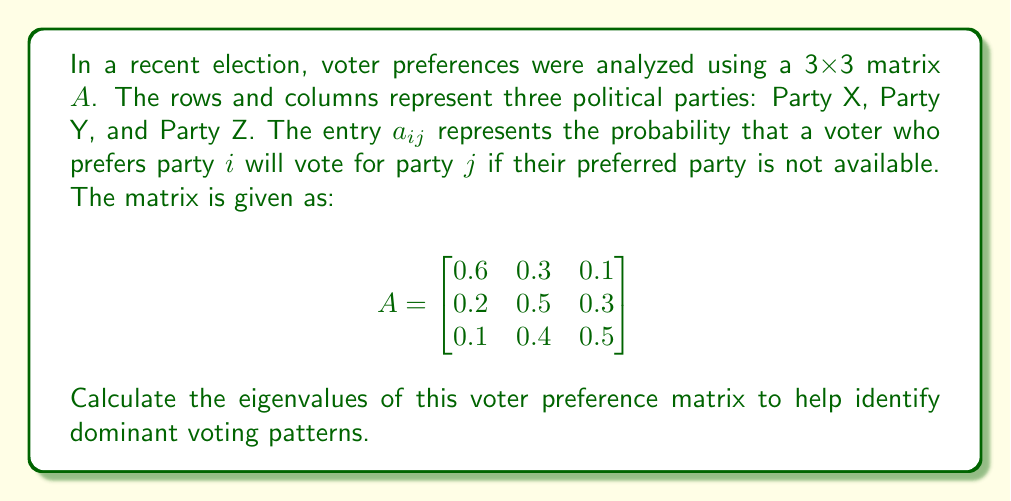Provide a solution to this math problem. To find the eigenvalues of matrix $A$, we need to solve the characteristic equation:

$\det(A - \lambda I) = 0$

where $I$ is the 3x3 identity matrix and $\lambda$ represents the eigenvalues.

Step 1: Set up the characteristic equation:
$$\det\begin{pmatrix}
0.6-\lambda & 0.3 & 0.1 \\
0.2 & 0.5-\lambda & 0.3 \\
0.1 & 0.4 & 0.5-\lambda
\end{pmatrix} = 0$$

Step 2: Expand the determinant:
$$(0.6-\lambda)[(0.5-\lambda)(0.5-\lambda) - 0.12] - 0.3[0.2(0.5-\lambda) - 0.03] + 0.1[0.08 - 0.2(0.5-\lambda)] = 0$$

Step 3: Simplify:
$$(0.6-\lambda)[(0.25-0.5\lambda+\lambda^2) - 0.12] - 0.3[0.1-0.2\lambda - 0.03] + 0.1[0.08 - 0.1+0.2\lambda] = 0$$
$$(0.6-\lambda)(0.13-0.5\lambda+\lambda^2) - 0.3(0.07-0.2\lambda) + 0.1(-0.02+0.2\lambda) = 0$$

Step 4: Expand and collect terms:
$$0.078 - 0.3\lambda + 0.6\lambda^2 - 0.13\lambda + 0.5\lambda^2 - \lambda^3 - 0.021 + 0.06\lambda - 0.002 + 0.02\lambda = 0$$
$$-\lambda^3 + 1.1\lambda^2 - 0.37\lambda + 0.055 = 0$$

Step 5: Solve the cubic equation. This can be done using the cubic formula or numerical methods. The solutions are:

$\lambda_1 \approx 1$
$\lambda_2 \approx 0.0771$
$\lambda_3 \approx 0.0229$

These eigenvalues represent the long-term voting patterns and stability of the preference system.
Answer: $\lambda_1 \approx 1$, $\lambda_2 \approx 0.0771$, $\lambda_3 \approx 0.0229$ 